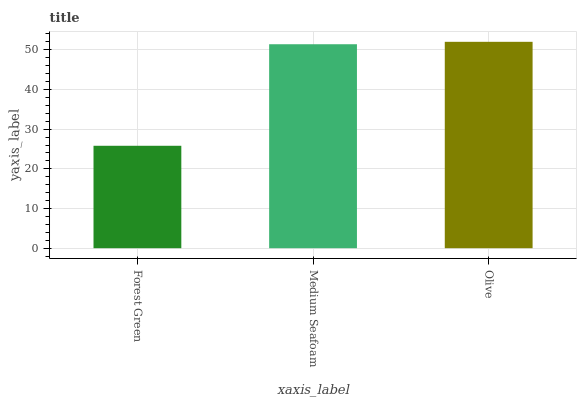Is Forest Green the minimum?
Answer yes or no. Yes. Is Olive the maximum?
Answer yes or no. Yes. Is Medium Seafoam the minimum?
Answer yes or no. No. Is Medium Seafoam the maximum?
Answer yes or no. No. Is Medium Seafoam greater than Forest Green?
Answer yes or no. Yes. Is Forest Green less than Medium Seafoam?
Answer yes or no. Yes. Is Forest Green greater than Medium Seafoam?
Answer yes or no. No. Is Medium Seafoam less than Forest Green?
Answer yes or no. No. Is Medium Seafoam the high median?
Answer yes or no. Yes. Is Medium Seafoam the low median?
Answer yes or no. Yes. Is Forest Green the high median?
Answer yes or no. No. Is Forest Green the low median?
Answer yes or no. No. 